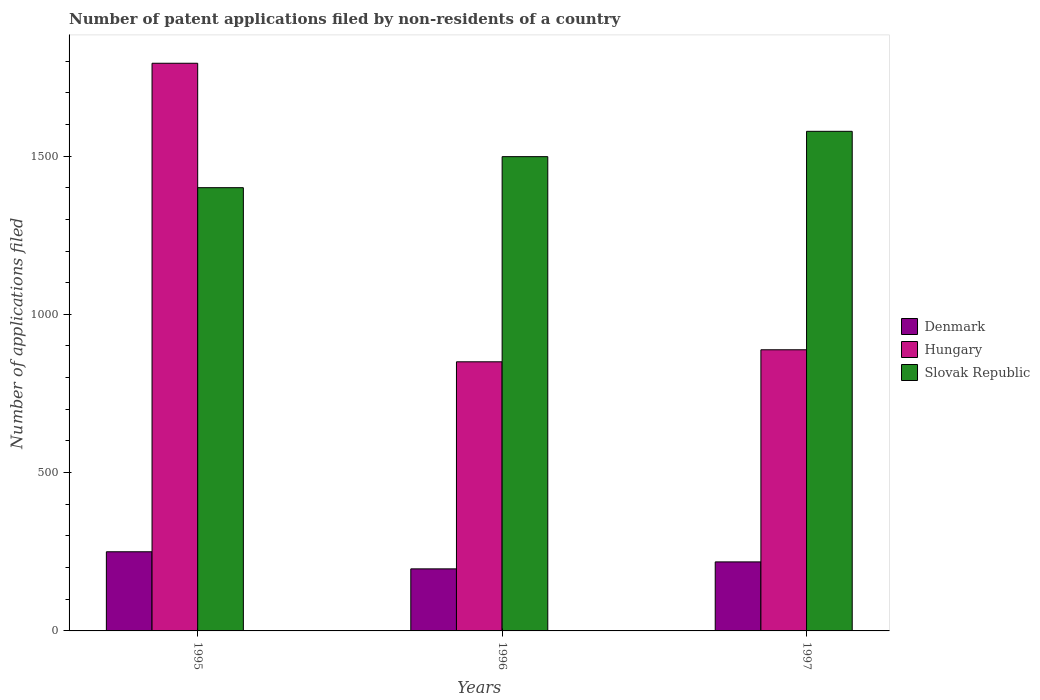How many groups of bars are there?
Provide a short and direct response. 3. Are the number of bars per tick equal to the number of legend labels?
Keep it short and to the point. Yes. How many bars are there on the 1st tick from the right?
Make the answer very short. 3. In how many cases, is the number of bars for a given year not equal to the number of legend labels?
Your answer should be compact. 0. What is the number of applications filed in Hungary in 1995?
Ensure brevity in your answer.  1793. Across all years, what is the maximum number of applications filed in Denmark?
Offer a terse response. 250. Across all years, what is the minimum number of applications filed in Hungary?
Your response must be concise. 850. What is the total number of applications filed in Slovak Republic in the graph?
Provide a succinct answer. 4476. What is the difference between the number of applications filed in Hungary in 1995 and that in 1996?
Keep it short and to the point. 943. What is the difference between the number of applications filed in Slovak Republic in 1997 and the number of applications filed in Hungary in 1995?
Ensure brevity in your answer.  -215. What is the average number of applications filed in Slovak Republic per year?
Your answer should be very brief. 1492. In the year 1995, what is the difference between the number of applications filed in Hungary and number of applications filed in Slovak Republic?
Your answer should be compact. 393. What is the ratio of the number of applications filed in Slovak Republic in 1996 to that in 1997?
Your answer should be compact. 0.95. Is the number of applications filed in Denmark in 1996 less than that in 1997?
Your answer should be very brief. Yes. What is the difference between the highest and the lowest number of applications filed in Hungary?
Provide a succinct answer. 943. In how many years, is the number of applications filed in Hungary greater than the average number of applications filed in Hungary taken over all years?
Your answer should be very brief. 1. Is the sum of the number of applications filed in Slovak Republic in 1995 and 1997 greater than the maximum number of applications filed in Denmark across all years?
Your answer should be compact. Yes. What does the 2nd bar from the left in 1995 represents?
Offer a very short reply. Hungary. What does the 3rd bar from the right in 1997 represents?
Your response must be concise. Denmark. Are all the bars in the graph horizontal?
Make the answer very short. No. How many years are there in the graph?
Offer a terse response. 3. Are the values on the major ticks of Y-axis written in scientific E-notation?
Provide a short and direct response. No. Does the graph contain any zero values?
Your response must be concise. No. Does the graph contain grids?
Provide a short and direct response. No. Where does the legend appear in the graph?
Offer a very short reply. Center right. How many legend labels are there?
Provide a short and direct response. 3. What is the title of the graph?
Offer a terse response. Number of patent applications filed by non-residents of a country. What is the label or title of the Y-axis?
Give a very brief answer. Number of applications filed. What is the Number of applications filed in Denmark in 1995?
Your answer should be compact. 250. What is the Number of applications filed of Hungary in 1995?
Provide a succinct answer. 1793. What is the Number of applications filed in Slovak Republic in 1995?
Offer a very short reply. 1400. What is the Number of applications filed in Denmark in 1996?
Keep it short and to the point. 196. What is the Number of applications filed of Hungary in 1996?
Provide a succinct answer. 850. What is the Number of applications filed in Slovak Republic in 1996?
Offer a very short reply. 1498. What is the Number of applications filed of Denmark in 1997?
Keep it short and to the point. 218. What is the Number of applications filed of Hungary in 1997?
Your response must be concise. 888. What is the Number of applications filed of Slovak Republic in 1997?
Ensure brevity in your answer.  1578. Across all years, what is the maximum Number of applications filed in Denmark?
Offer a terse response. 250. Across all years, what is the maximum Number of applications filed of Hungary?
Your answer should be very brief. 1793. Across all years, what is the maximum Number of applications filed in Slovak Republic?
Your response must be concise. 1578. Across all years, what is the minimum Number of applications filed in Denmark?
Make the answer very short. 196. Across all years, what is the minimum Number of applications filed in Hungary?
Your response must be concise. 850. Across all years, what is the minimum Number of applications filed of Slovak Republic?
Make the answer very short. 1400. What is the total Number of applications filed of Denmark in the graph?
Give a very brief answer. 664. What is the total Number of applications filed in Hungary in the graph?
Provide a short and direct response. 3531. What is the total Number of applications filed of Slovak Republic in the graph?
Your response must be concise. 4476. What is the difference between the Number of applications filed in Denmark in 1995 and that in 1996?
Make the answer very short. 54. What is the difference between the Number of applications filed in Hungary in 1995 and that in 1996?
Offer a very short reply. 943. What is the difference between the Number of applications filed of Slovak Republic in 1995 and that in 1996?
Offer a terse response. -98. What is the difference between the Number of applications filed in Hungary in 1995 and that in 1997?
Make the answer very short. 905. What is the difference between the Number of applications filed in Slovak Republic in 1995 and that in 1997?
Provide a short and direct response. -178. What is the difference between the Number of applications filed of Denmark in 1996 and that in 1997?
Provide a succinct answer. -22. What is the difference between the Number of applications filed in Hungary in 1996 and that in 1997?
Your answer should be compact. -38. What is the difference between the Number of applications filed of Slovak Republic in 1996 and that in 1997?
Make the answer very short. -80. What is the difference between the Number of applications filed of Denmark in 1995 and the Number of applications filed of Hungary in 1996?
Your answer should be compact. -600. What is the difference between the Number of applications filed in Denmark in 1995 and the Number of applications filed in Slovak Republic in 1996?
Your answer should be very brief. -1248. What is the difference between the Number of applications filed of Hungary in 1995 and the Number of applications filed of Slovak Republic in 1996?
Your answer should be very brief. 295. What is the difference between the Number of applications filed of Denmark in 1995 and the Number of applications filed of Hungary in 1997?
Offer a terse response. -638. What is the difference between the Number of applications filed of Denmark in 1995 and the Number of applications filed of Slovak Republic in 1997?
Keep it short and to the point. -1328. What is the difference between the Number of applications filed of Hungary in 1995 and the Number of applications filed of Slovak Republic in 1997?
Make the answer very short. 215. What is the difference between the Number of applications filed of Denmark in 1996 and the Number of applications filed of Hungary in 1997?
Your response must be concise. -692. What is the difference between the Number of applications filed in Denmark in 1996 and the Number of applications filed in Slovak Republic in 1997?
Your answer should be very brief. -1382. What is the difference between the Number of applications filed of Hungary in 1996 and the Number of applications filed of Slovak Republic in 1997?
Your answer should be compact. -728. What is the average Number of applications filed in Denmark per year?
Ensure brevity in your answer.  221.33. What is the average Number of applications filed of Hungary per year?
Keep it short and to the point. 1177. What is the average Number of applications filed of Slovak Republic per year?
Provide a succinct answer. 1492. In the year 1995, what is the difference between the Number of applications filed of Denmark and Number of applications filed of Hungary?
Ensure brevity in your answer.  -1543. In the year 1995, what is the difference between the Number of applications filed of Denmark and Number of applications filed of Slovak Republic?
Keep it short and to the point. -1150. In the year 1995, what is the difference between the Number of applications filed of Hungary and Number of applications filed of Slovak Republic?
Keep it short and to the point. 393. In the year 1996, what is the difference between the Number of applications filed of Denmark and Number of applications filed of Hungary?
Offer a terse response. -654. In the year 1996, what is the difference between the Number of applications filed in Denmark and Number of applications filed in Slovak Republic?
Keep it short and to the point. -1302. In the year 1996, what is the difference between the Number of applications filed in Hungary and Number of applications filed in Slovak Republic?
Keep it short and to the point. -648. In the year 1997, what is the difference between the Number of applications filed in Denmark and Number of applications filed in Hungary?
Give a very brief answer. -670. In the year 1997, what is the difference between the Number of applications filed of Denmark and Number of applications filed of Slovak Republic?
Provide a short and direct response. -1360. In the year 1997, what is the difference between the Number of applications filed of Hungary and Number of applications filed of Slovak Republic?
Offer a terse response. -690. What is the ratio of the Number of applications filed of Denmark in 1995 to that in 1996?
Provide a succinct answer. 1.28. What is the ratio of the Number of applications filed of Hungary in 1995 to that in 1996?
Offer a very short reply. 2.11. What is the ratio of the Number of applications filed of Slovak Republic in 1995 to that in 1996?
Ensure brevity in your answer.  0.93. What is the ratio of the Number of applications filed in Denmark in 1995 to that in 1997?
Offer a terse response. 1.15. What is the ratio of the Number of applications filed of Hungary in 1995 to that in 1997?
Provide a succinct answer. 2.02. What is the ratio of the Number of applications filed of Slovak Republic in 1995 to that in 1997?
Offer a very short reply. 0.89. What is the ratio of the Number of applications filed in Denmark in 1996 to that in 1997?
Keep it short and to the point. 0.9. What is the ratio of the Number of applications filed in Hungary in 1996 to that in 1997?
Offer a very short reply. 0.96. What is the ratio of the Number of applications filed in Slovak Republic in 1996 to that in 1997?
Your answer should be very brief. 0.95. What is the difference between the highest and the second highest Number of applications filed in Hungary?
Offer a terse response. 905. What is the difference between the highest and the lowest Number of applications filed in Hungary?
Keep it short and to the point. 943. What is the difference between the highest and the lowest Number of applications filed in Slovak Republic?
Keep it short and to the point. 178. 